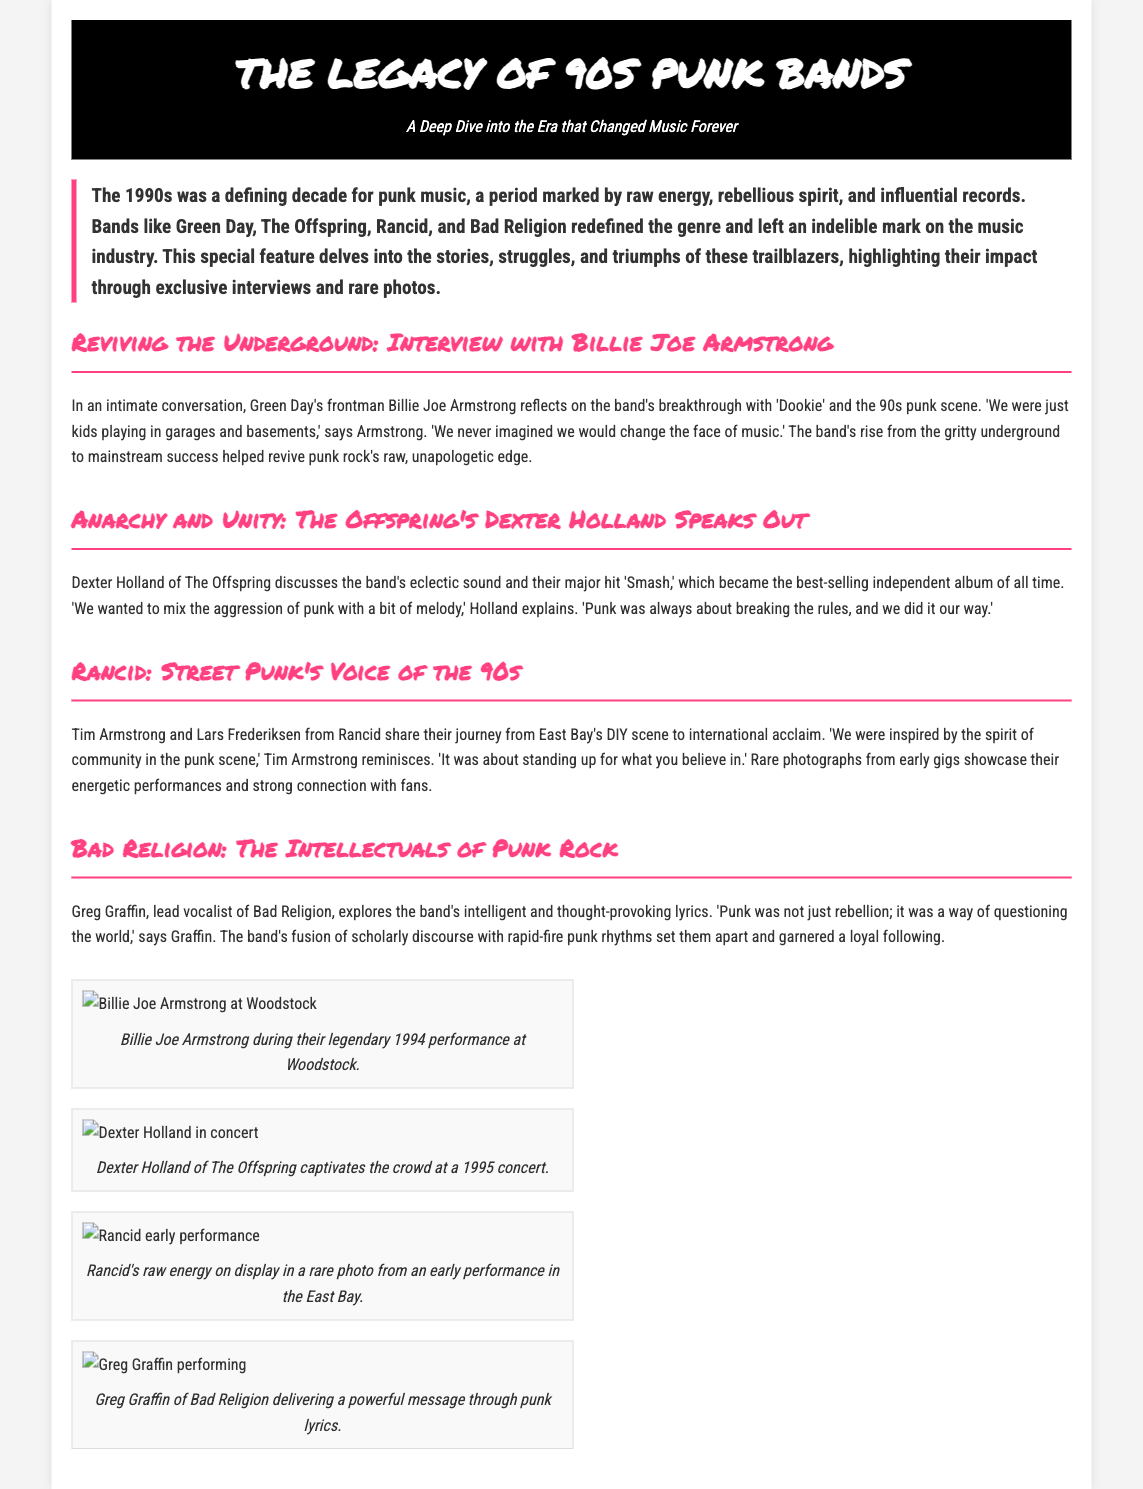what is the title of the article? The title of the article is prominently displayed at the top of the document, highlighting the focus on 90s punk bands.
Answer: The Legacy of 90s Punk Bands who is the frontman of Green Day? Billie Joe Armstrong is mentioned as the frontman of Green Day in the interviews section.
Answer: Billie Joe Armstrong what major album did The Offspring release? The document references 'Smash' as The Offspring's major album that became the best-selling independent album of all time.
Answer: Smash who are the members of Rancid interviewed in the article? The document states that Tim Armstrong and Lars Frederiksen from Rancid shared their journey in the interviews section.
Answer: Tim Armstrong and Lars Frederiksen what notable festival performance is mentioned for Green Day? The article highlights Billie Joe Armstrong's performance at Woodstock as a significant event for Green Day.
Answer: Woodstock what genre of music is primarily discussed in the article? The focus of the article is specifically on a music genre known for its raw energy and rebellious nature.
Answer: Punk what type of images are included in the photo gallery? The photo gallery features images related to the performances and appearances of the interviewed bands.
Answer: Rare photos which band's lyrics are described as thought-provoking? Bad Religion's lyrics are described as intelligent and thought-provoking in their section of the article.
Answer: Bad Religion what year does the article imply as defining for 90s punk music? The article refers specifically to a decade that marked the evolution and influence of punk music around that time.
Answer: 1990s 